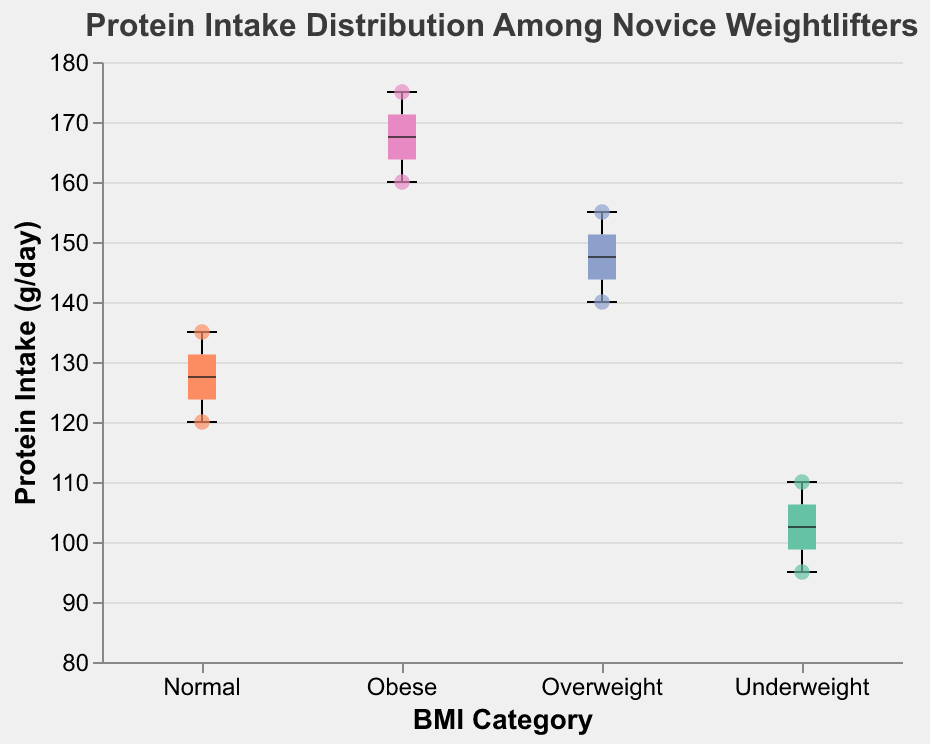What is the title of the figure? The title of the figure is displayed at the top in bold and larger font size.
Answer: Protein Intake Distribution Among Novice Weightlifters Which BMI category has the highest median protein intake? The highest median protein intake is shown by the thick black line within each boxplot. Notice which category rises the highest.
Answer: Obese What is the range of protein intake for the 'Normal' BMI group? The range is the difference between the highest and the lowest points within the boxplot for the 'Normal' BMI group.
Answer: 120 g/day to 135 g/day How many weightlifters are there in the 'Underweight' BMI category? Count the number of scatter points shown within the 'Underweight' group.
Answer: 4 Which BMI category has the most variability in protein intake? Variability is indicated by the length of the boxplot. Identify which group has the longest boxplot.
Answer: Obese For the 'Overweight' category, what is the interquartile range (IQR) of protein intake? The IQR is the range between the first quartile (bottom edge of the box) and the third quartile (top edge of the box) in the boxplot.
Answer: 145 g/day to 150 g/day Who is the weightlifter with the maximum protein intake, and what is their BMI category? Locate the highest scatter point and read off the accompanying BMI category and name.
Answer: Nina, Obese Compare the median protein intake of the 'Underweight' and 'Overweight' BMI categories. Which is higher and by how much? Refer to the median lines of the underweight and overweight groups and compute the difference.
Answer: Overweight is higher by 40 g/day What color represents the 'Underweight' BMI category in the plot? Look for the color associated with the 'Underweight' markers and boxplot.
Answer: Green Which category shows the least scatter in individual protein intake values? Identify the category with the least spread in scatter points around the boxplot.
Answer: Normal 